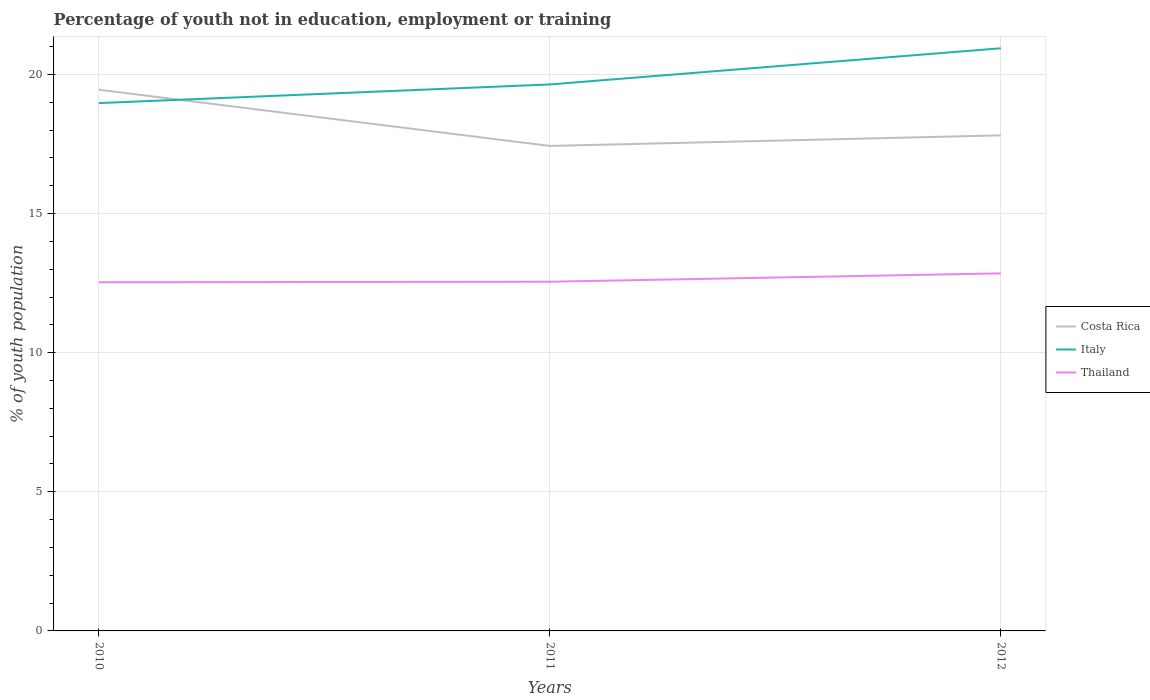Is the number of lines equal to the number of legend labels?
Keep it short and to the point. Yes. Across all years, what is the maximum percentage of unemployed youth population in in Costa Rica?
Provide a short and direct response. 17.43. What is the total percentage of unemployed youth population in in Italy in the graph?
Make the answer very short. -1.3. What is the difference between the highest and the second highest percentage of unemployed youth population in in Thailand?
Offer a very short reply. 0.32. Is the percentage of unemployed youth population in in Thailand strictly greater than the percentage of unemployed youth population in in Costa Rica over the years?
Ensure brevity in your answer.  Yes. What is the difference between two consecutive major ticks on the Y-axis?
Provide a succinct answer. 5. Are the values on the major ticks of Y-axis written in scientific E-notation?
Your answer should be compact. No. Does the graph contain any zero values?
Provide a succinct answer. No. What is the title of the graph?
Ensure brevity in your answer.  Percentage of youth not in education, employment or training. What is the label or title of the X-axis?
Ensure brevity in your answer.  Years. What is the label or title of the Y-axis?
Offer a terse response. % of youth population. What is the % of youth population of Costa Rica in 2010?
Ensure brevity in your answer.  19.45. What is the % of youth population in Italy in 2010?
Offer a terse response. 18.97. What is the % of youth population in Thailand in 2010?
Keep it short and to the point. 12.53. What is the % of youth population in Costa Rica in 2011?
Make the answer very short. 17.43. What is the % of youth population in Italy in 2011?
Give a very brief answer. 19.64. What is the % of youth population in Thailand in 2011?
Provide a succinct answer. 12.55. What is the % of youth population in Costa Rica in 2012?
Give a very brief answer. 17.81. What is the % of youth population of Italy in 2012?
Provide a succinct answer. 20.94. What is the % of youth population in Thailand in 2012?
Ensure brevity in your answer.  12.85. Across all years, what is the maximum % of youth population in Costa Rica?
Provide a succinct answer. 19.45. Across all years, what is the maximum % of youth population in Italy?
Keep it short and to the point. 20.94. Across all years, what is the maximum % of youth population of Thailand?
Your answer should be very brief. 12.85. Across all years, what is the minimum % of youth population of Costa Rica?
Keep it short and to the point. 17.43. Across all years, what is the minimum % of youth population of Italy?
Offer a very short reply. 18.97. Across all years, what is the minimum % of youth population in Thailand?
Make the answer very short. 12.53. What is the total % of youth population in Costa Rica in the graph?
Provide a short and direct response. 54.69. What is the total % of youth population of Italy in the graph?
Provide a succinct answer. 59.55. What is the total % of youth population in Thailand in the graph?
Offer a terse response. 37.93. What is the difference between the % of youth population of Costa Rica in 2010 and that in 2011?
Keep it short and to the point. 2.02. What is the difference between the % of youth population in Italy in 2010 and that in 2011?
Offer a terse response. -0.67. What is the difference between the % of youth population of Thailand in 2010 and that in 2011?
Provide a succinct answer. -0.02. What is the difference between the % of youth population of Costa Rica in 2010 and that in 2012?
Offer a very short reply. 1.64. What is the difference between the % of youth population in Italy in 2010 and that in 2012?
Give a very brief answer. -1.97. What is the difference between the % of youth population of Thailand in 2010 and that in 2012?
Provide a succinct answer. -0.32. What is the difference between the % of youth population of Costa Rica in 2011 and that in 2012?
Your answer should be compact. -0.38. What is the difference between the % of youth population in Thailand in 2011 and that in 2012?
Ensure brevity in your answer.  -0.3. What is the difference between the % of youth population in Costa Rica in 2010 and the % of youth population in Italy in 2011?
Your response must be concise. -0.19. What is the difference between the % of youth population of Costa Rica in 2010 and the % of youth population of Thailand in 2011?
Offer a terse response. 6.9. What is the difference between the % of youth population of Italy in 2010 and the % of youth population of Thailand in 2011?
Provide a succinct answer. 6.42. What is the difference between the % of youth population of Costa Rica in 2010 and the % of youth population of Italy in 2012?
Your answer should be compact. -1.49. What is the difference between the % of youth population in Costa Rica in 2010 and the % of youth population in Thailand in 2012?
Provide a succinct answer. 6.6. What is the difference between the % of youth population of Italy in 2010 and the % of youth population of Thailand in 2012?
Your response must be concise. 6.12. What is the difference between the % of youth population in Costa Rica in 2011 and the % of youth population in Italy in 2012?
Make the answer very short. -3.51. What is the difference between the % of youth population in Costa Rica in 2011 and the % of youth population in Thailand in 2012?
Keep it short and to the point. 4.58. What is the difference between the % of youth population in Italy in 2011 and the % of youth population in Thailand in 2012?
Your response must be concise. 6.79. What is the average % of youth population in Costa Rica per year?
Provide a succinct answer. 18.23. What is the average % of youth population in Italy per year?
Offer a very short reply. 19.85. What is the average % of youth population of Thailand per year?
Provide a short and direct response. 12.64. In the year 2010, what is the difference between the % of youth population in Costa Rica and % of youth population in Italy?
Provide a short and direct response. 0.48. In the year 2010, what is the difference between the % of youth population in Costa Rica and % of youth population in Thailand?
Offer a terse response. 6.92. In the year 2010, what is the difference between the % of youth population in Italy and % of youth population in Thailand?
Give a very brief answer. 6.44. In the year 2011, what is the difference between the % of youth population of Costa Rica and % of youth population of Italy?
Offer a very short reply. -2.21. In the year 2011, what is the difference between the % of youth population in Costa Rica and % of youth population in Thailand?
Provide a succinct answer. 4.88. In the year 2011, what is the difference between the % of youth population in Italy and % of youth population in Thailand?
Provide a short and direct response. 7.09. In the year 2012, what is the difference between the % of youth population of Costa Rica and % of youth population of Italy?
Give a very brief answer. -3.13. In the year 2012, what is the difference between the % of youth population in Costa Rica and % of youth population in Thailand?
Your response must be concise. 4.96. In the year 2012, what is the difference between the % of youth population in Italy and % of youth population in Thailand?
Ensure brevity in your answer.  8.09. What is the ratio of the % of youth population in Costa Rica in 2010 to that in 2011?
Your response must be concise. 1.12. What is the ratio of the % of youth population in Italy in 2010 to that in 2011?
Your answer should be compact. 0.97. What is the ratio of the % of youth population of Costa Rica in 2010 to that in 2012?
Give a very brief answer. 1.09. What is the ratio of the % of youth population in Italy in 2010 to that in 2012?
Your response must be concise. 0.91. What is the ratio of the % of youth population in Thailand in 2010 to that in 2012?
Provide a succinct answer. 0.98. What is the ratio of the % of youth population in Costa Rica in 2011 to that in 2012?
Give a very brief answer. 0.98. What is the ratio of the % of youth population in Italy in 2011 to that in 2012?
Provide a succinct answer. 0.94. What is the ratio of the % of youth population in Thailand in 2011 to that in 2012?
Your response must be concise. 0.98. What is the difference between the highest and the second highest % of youth population in Costa Rica?
Your answer should be compact. 1.64. What is the difference between the highest and the second highest % of youth population of Italy?
Your response must be concise. 1.3. What is the difference between the highest and the lowest % of youth population of Costa Rica?
Keep it short and to the point. 2.02. What is the difference between the highest and the lowest % of youth population of Italy?
Provide a short and direct response. 1.97. What is the difference between the highest and the lowest % of youth population in Thailand?
Provide a short and direct response. 0.32. 